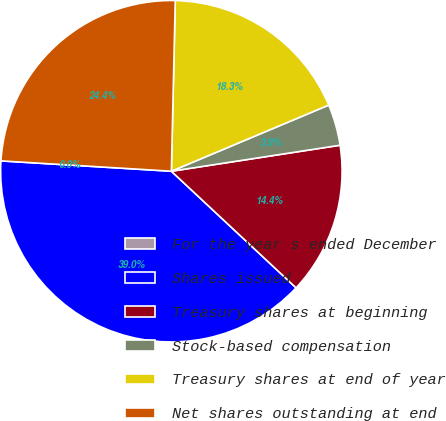Convert chart to OTSL. <chart><loc_0><loc_0><loc_500><loc_500><pie_chart><fcel>For the year s ended December<fcel>Shares issued<fcel>Treasury shares at beginning<fcel>Stock-based compensation<fcel>Treasury shares at end of year<fcel>Net shares outstanding at end<nl><fcel>0.0%<fcel>39.0%<fcel>14.4%<fcel>3.9%<fcel>18.3%<fcel>24.4%<nl></chart> 